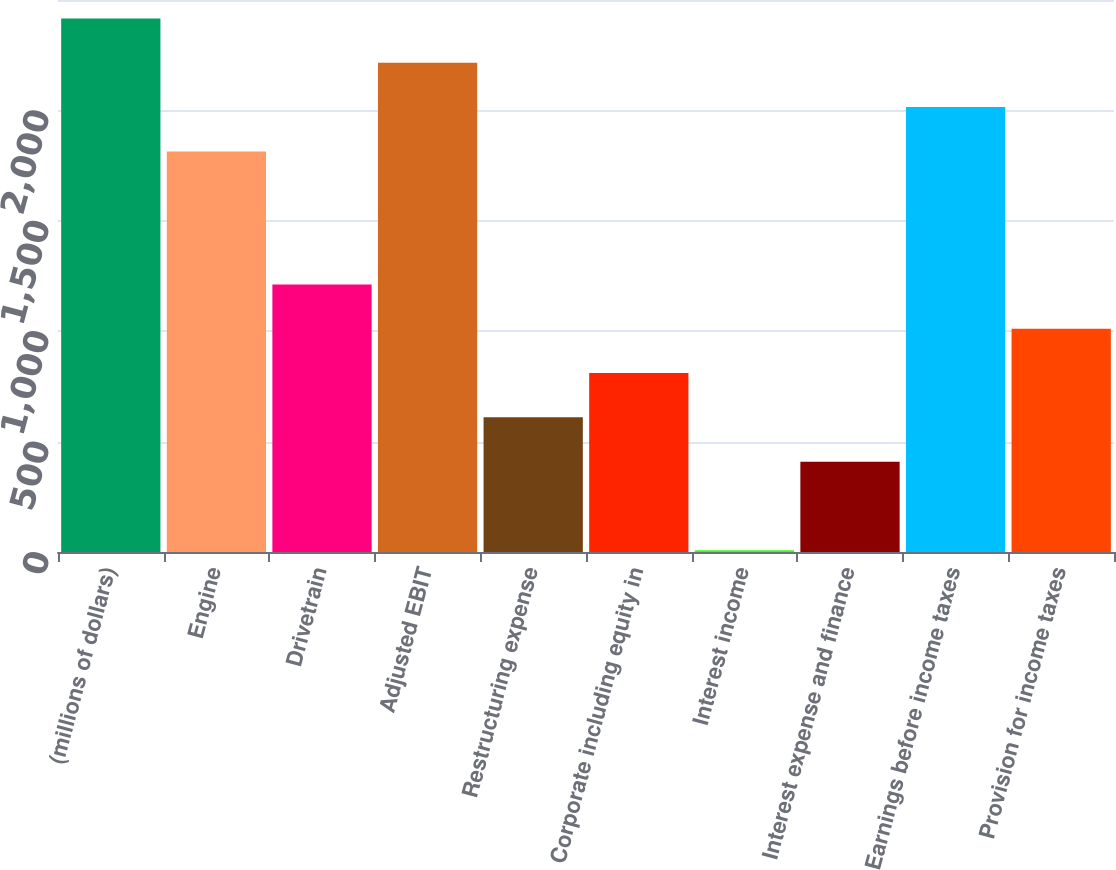Convert chart to OTSL. <chart><loc_0><loc_0><loc_500><loc_500><bar_chart><fcel>(millions of dollars)<fcel>Engine<fcel>Drivetrain<fcel>Adjusted EBIT<fcel>Restructuring expense<fcel>Corporate including equity in<fcel>Interest income<fcel>Interest expense and finance<fcel>Earnings before income taxes<fcel>Provision for income taxes<nl><fcel>2416.5<fcel>1814.25<fcel>1212<fcel>2215.75<fcel>609.75<fcel>810.5<fcel>7.5<fcel>409<fcel>2015<fcel>1011.25<nl></chart> 